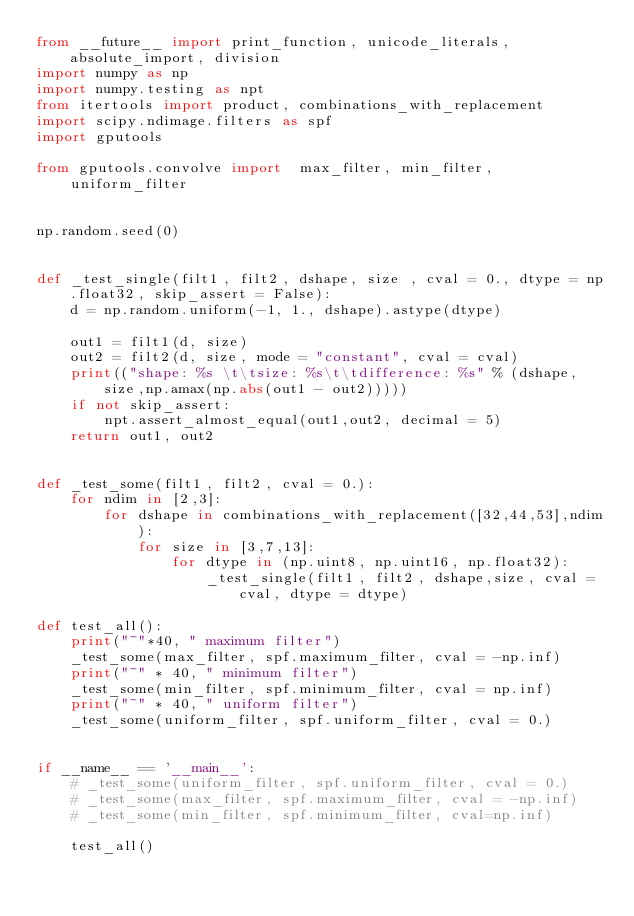Convert code to text. <code><loc_0><loc_0><loc_500><loc_500><_Python_>from __future__ import print_function, unicode_literals, absolute_import, division
import numpy as np
import numpy.testing as npt
from itertools import product, combinations_with_replacement
import scipy.ndimage.filters as spf
import gputools

from gputools.convolve import  max_filter, min_filter, uniform_filter


np.random.seed(0)


def _test_single(filt1, filt2, dshape, size , cval = 0., dtype = np.float32, skip_assert = False):
    d = np.random.uniform(-1, 1., dshape).astype(dtype)

    out1 = filt1(d, size)
    out2 = filt2(d, size, mode = "constant", cval = cval)
    print(("shape: %s \t\tsize: %s\t\tdifference: %s" % (dshape, size,np.amax(np.abs(out1 - out2)))))
    if not skip_assert:
        npt.assert_almost_equal(out1,out2, decimal = 5)
    return out1, out2


def _test_some(filt1, filt2, cval = 0.):
    for ndim in [2,3]:
        for dshape in combinations_with_replacement([32,44,53],ndim):
            for size in [3,7,13]:
                for dtype in (np.uint8, np.uint16, np.float32):
                    _test_single(filt1, filt2, dshape,size, cval = cval, dtype = dtype)

def test_all():
    print("~"*40, " maximum filter")
    _test_some(max_filter, spf.maximum_filter, cval = -np.inf)
    print("~" * 40, " minimum filter")
    _test_some(min_filter, spf.minimum_filter, cval = np.inf)
    print("~" * 40, " uniform filter")
    _test_some(uniform_filter, spf.uniform_filter, cval = 0.)


if __name__ == '__main__':
    # _test_some(uniform_filter, spf.uniform_filter, cval = 0.)
    # _test_some(max_filter, spf.maximum_filter, cval = -np.inf)
    # _test_some(min_filter, spf.minimum_filter, cval=np.inf)

    test_all()
</code> 